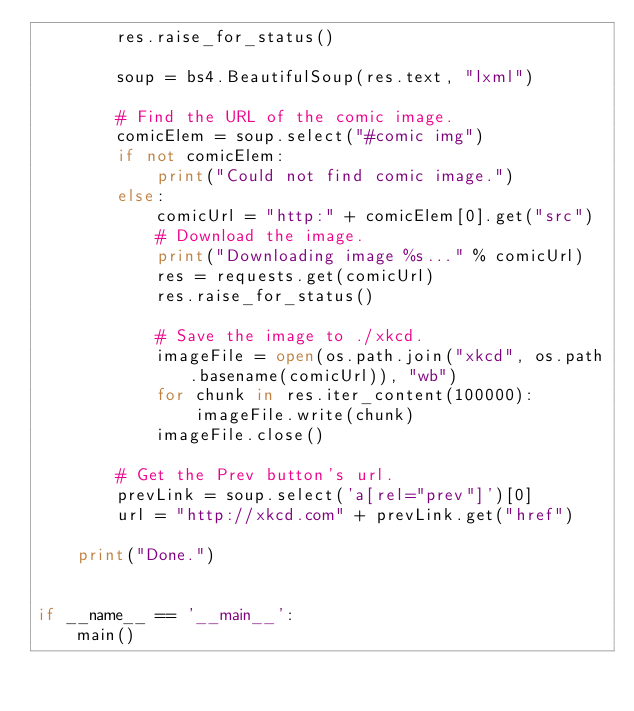<code> <loc_0><loc_0><loc_500><loc_500><_Python_>        res.raise_for_status()

        soup = bs4.BeautifulSoup(res.text, "lxml")

        # Find the URL of the comic image.
        comicElem = soup.select("#comic img")
        if not comicElem:
            print("Could not find comic image.")
        else:
            comicUrl = "http:" + comicElem[0].get("src")
            # Download the image.
            print("Downloading image %s..." % comicUrl)
            res = requests.get(comicUrl)
            res.raise_for_status()

            # Save the image to ./xkcd.
            imageFile = open(os.path.join("xkcd", os.path.basename(comicUrl)), "wb")
            for chunk in res.iter_content(100000):
                imageFile.write(chunk)
            imageFile.close()

        # Get the Prev button's url.
        prevLink = soup.select('a[rel="prev"]')[0]
        url = "http://xkcd.com" + prevLink.get("href")

    print("Done.")


if __name__ == '__main__':
    main()
</code> 